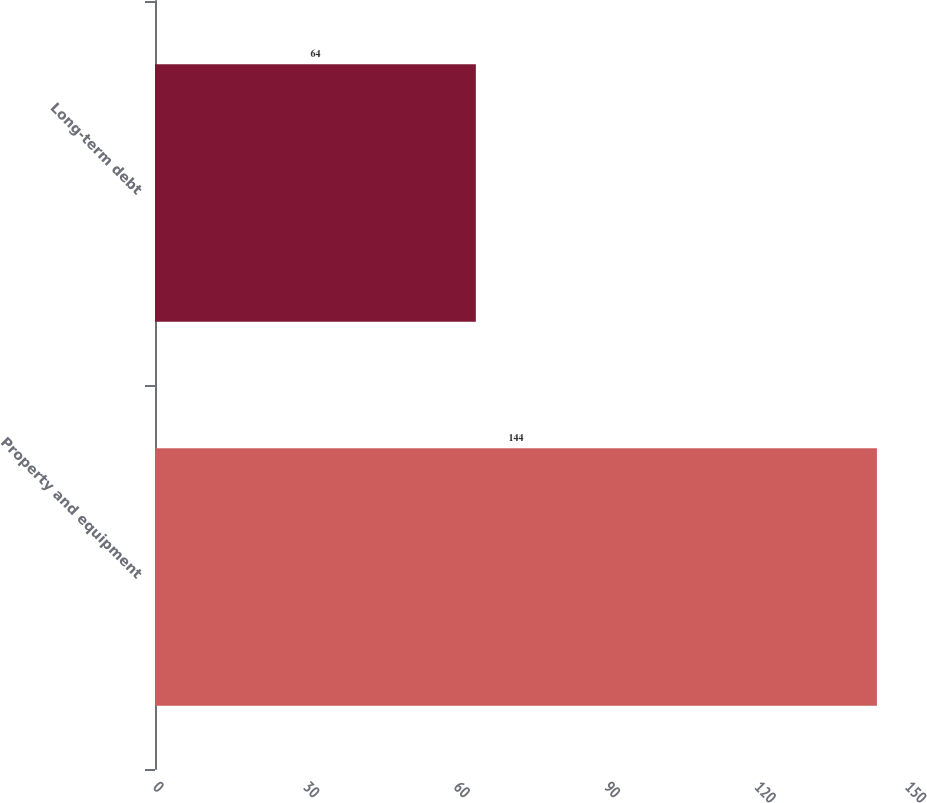Convert chart to OTSL. <chart><loc_0><loc_0><loc_500><loc_500><bar_chart><fcel>Property and equipment<fcel>Long-term debt<nl><fcel>144<fcel>64<nl></chart> 